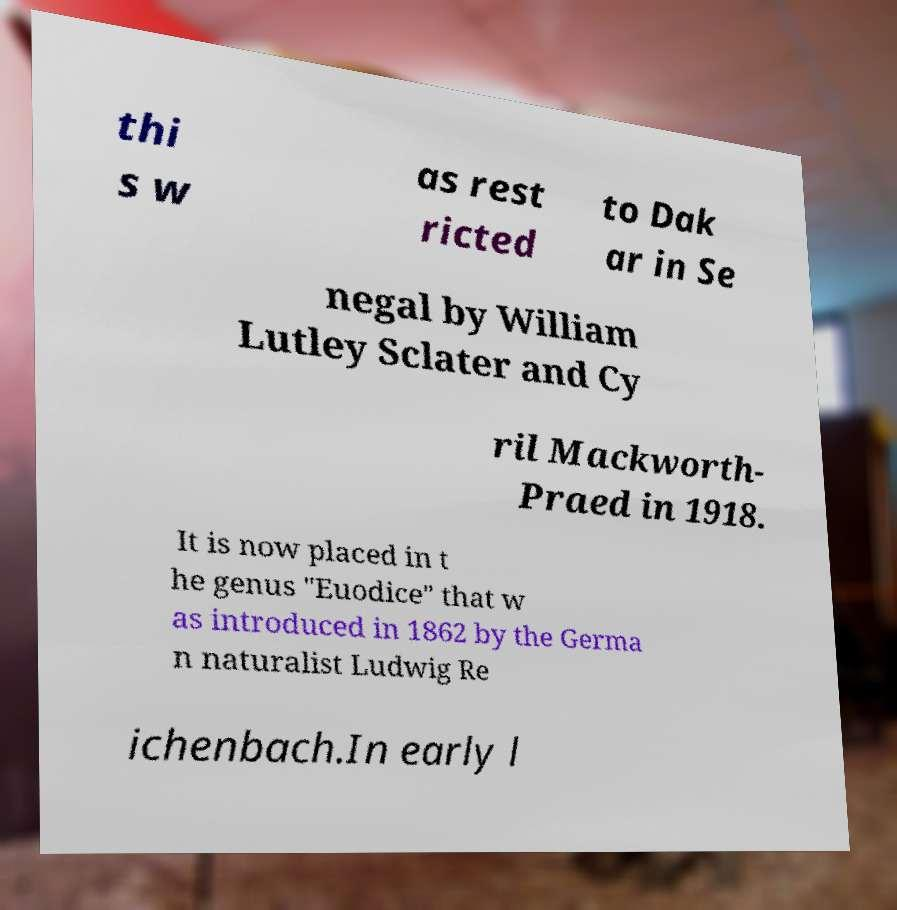Please read and relay the text visible in this image. What does it say? thi s w as rest ricted to Dak ar in Se negal by William Lutley Sclater and Cy ril Mackworth- Praed in 1918. It is now placed in t he genus "Euodice" that w as introduced in 1862 by the Germa n naturalist Ludwig Re ichenbach.In early l 